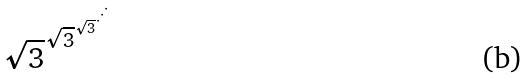<formula> <loc_0><loc_0><loc_500><loc_500>\sqrt { 3 } ^ { \sqrt { 3 } ^ { \sqrt { 3 } ^ { \cdot ^ { \cdot ^ { \cdot } } } } }</formula> 